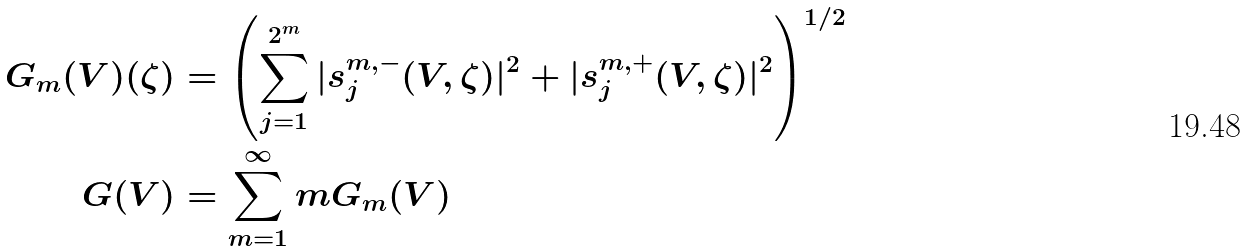<formula> <loc_0><loc_0><loc_500><loc_500>G _ { m } ( V ) ( \zeta ) & = \left ( \sum _ { j = 1 } ^ { 2 ^ { m } } | s ^ { m , - } _ { j } ( V , \zeta ) | ^ { 2 } + | s ^ { m , + } _ { j } ( V , \zeta ) | ^ { 2 } \right ) ^ { 1 / 2 } \\ G ( V ) & = \sum _ { m = 1 } ^ { \infty } m G _ { m } ( V )</formula> 